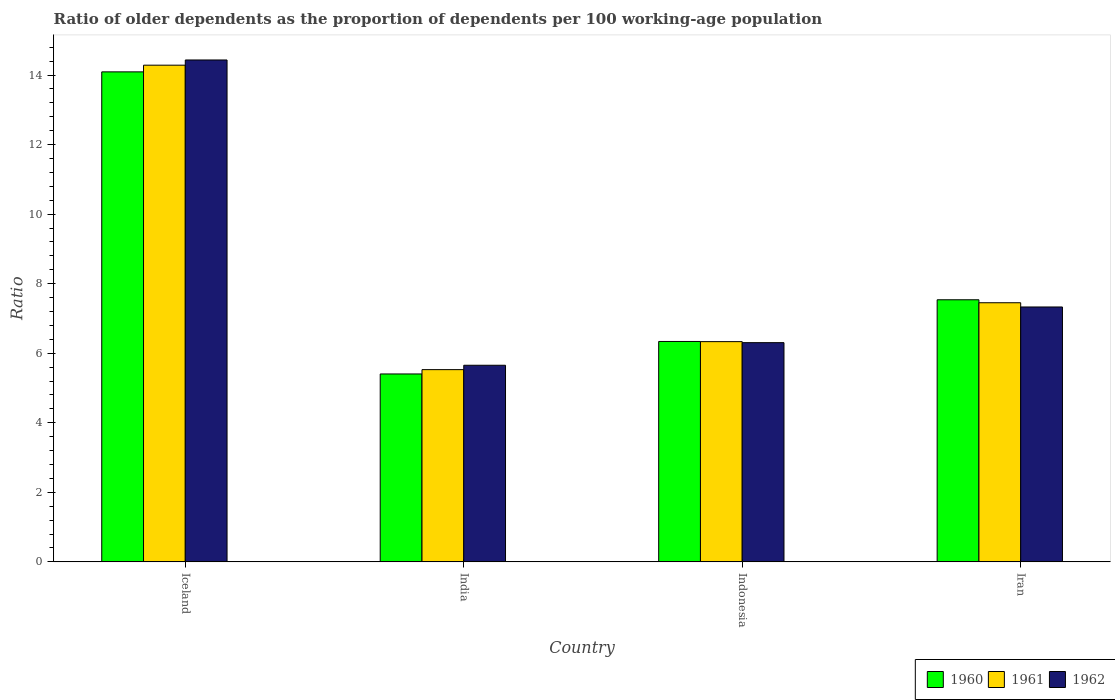How many groups of bars are there?
Your answer should be compact. 4. Are the number of bars per tick equal to the number of legend labels?
Offer a very short reply. Yes. What is the age dependency ratio(old) in 1960 in Iceland?
Your answer should be very brief. 14.09. Across all countries, what is the maximum age dependency ratio(old) in 1960?
Provide a short and direct response. 14.09. Across all countries, what is the minimum age dependency ratio(old) in 1962?
Offer a terse response. 5.65. In which country was the age dependency ratio(old) in 1962 maximum?
Offer a very short reply. Iceland. In which country was the age dependency ratio(old) in 1960 minimum?
Make the answer very short. India. What is the total age dependency ratio(old) in 1962 in the graph?
Keep it short and to the point. 33.72. What is the difference between the age dependency ratio(old) in 1962 in Iceland and that in Iran?
Give a very brief answer. 7.1. What is the difference between the age dependency ratio(old) in 1962 in Indonesia and the age dependency ratio(old) in 1961 in India?
Offer a terse response. 0.78. What is the average age dependency ratio(old) in 1961 per country?
Offer a terse response. 8.4. What is the difference between the age dependency ratio(old) of/in 1960 and age dependency ratio(old) of/in 1962 in Iceland?
Provide a succinct answer. -0.34. What is the ratio of the age dependency ratio(old) in 1961 in Iceland to that in India?
Give a very brief answer. 2.58. What is the difference between the highest and the second highest age dependency ratio(old) in 1960?
Your answer should be very brief. -7.75. What is the difference between the highest and the lowest age dependency ratio(old) in 1961?
Provide a succinct answer. 8.75. What does the 3rd bar from the left in Iran represents?
Give a very brief answer. 1962. What does the 2nd bar from the right in Indonesia represents?
Give a very brief answer. 1961. Is it the case that in every country, the sum of the age dependency ratio(old) in 1961 and age dependency ratio(old) in 1962 is greater than the age dependency ratio(old) in 1960?
Provide a short and direct response. Yes. What is the difference between two consecutive major ticks on the Y-axis?
Provide a short and direct response. 2. Does the graph contain any zero values?
Offer a terse response. No. Does the graph contain grids?
Offer a terse response. No. What is the title of the graph?
Provide a short and direct response. Ratio of older dependents as the proportion of dependents per 100 working-age population. Does "1994" appear as one of the legend labels in the graph?
Make the answer very short. No. What is the label or title of the X-axis?
Provide a short and direct response. Country. What is the label or title of the Y-axis?
Keep it short and to the point. Ratio. What is the Ratio in 1960 in Iceland?
Your answer should be compact. 14.09. What is the Ratio of 1961 in Iceland?
Your answer should be compact. 14.28. What is the Ratio of 1962 in Iceland?
Ensure brevity in your answer.  14.43. What is the Ratio in 1960 in India?
Your answer should be very brief. 5.4. What is the Ratio in 1961 in India?
Offer a very short reply. 5.53. What is the Ratio in 1962 in India?
Your response must be concise. 5.65. What is the Ratio in 1960 in Indonesia?
Offer a terse response. 6.34. What is the Ratio of 1961 in Indonesia?
Ensure brevity in your answer.  6.33. What is the Ratio of 1962 in Indonesia?
Make the answer very short. 6.3. What is the Ratio of 1960 in Iran?
Provide a short and direct response. 7.54. What is the Ratio of 1961 in Iran?
Your answer should be compact. 7.45. What is the Ratio in 1962 in Iran?
Provide a short and direct response. 7.33. Across all countries, what is the maximum Ratio of 1960?
Your answer should be very brief. 14.09. Across all countries, what is the maximum Ratio of 1961?
Keep it short and to the point. 14.28. Across all countries, what is the maximum Ratio in 1962?
Your answer should be very brief. 14.43. Across all countries, what is the minimum Ratio in 1960?
Provide a succinct answer. 5.4. Across all countries, what is the minimum Ratio of 1961?
Provide a succinct answer. 5.53. Across all countries, what is the minimum Ratio in 1962?
Make the answer very short. 5.65. What is the total Ratio in 1960 in the graph?
Keep it short and to the point. 33.37. What is the total Ratio of 1961 in the graph?
Ensure brevity in your answer.  33.6. What is the total Ratio in 1962 in the graph?
Ensure brevity in your answer.  33.72. What is the difference between the Ratio of 1960 in Iceland and that in India?
Provide a short and direct response. 8.69. What is the difference between the Ratio in 1961 in Iceland and that in India?
Your answer should be compact. 8.76. What is the difference between the Ratio of 1962 in Iceland and that in India?
Make the answer very short. 8.78. What is the difference between the Ratio of 1960 in Iceland and that in Indonesia?
Give a very brief answer. 7.75. What is the difference between the Ratio in 1961 in Iceland and that in Indonesia?
Provide a succinct answer. 7.95. What is the difference between the Ratio of 1962 in Iceland and that in Indonesia?
Offer a very short reply. 8.13. What is the difference between the Ratio in 1960 in Iceland and that in Iran?
Ensure brevity in your answer.  6.55. What is the difference between the Ratio of 1961 in Iceland and that in Iran?
Keep it short and to the point. 6.83. What is the difference between the Ratio of 1962 in Iceland and that in Iran?
Give a very brief answer. 7.1. What is the difference between the Ratio of 1960 in India and that in Indonesia?
Keep it short and to the point. -0.93. What is the difference between the Ratio of 1961 in India and that in Indonesia?
Keep it short and to the point. -0.81. What is the difference between the Ratio of 1962 in India and that in Indonesia?
Offer a very short reply. -0.65. What is the difference between the Ratio of 1960 in India and that in Iran?
Make the answer very short. -2.13. What is the difference between the Ratio of 1961 in India and that in Iran?
Keep it short and to the point. -1.92. What is the difference between the Ratio in 1962 in India and that in Iran?
Ensure brevity in your answer.  -1.68. What is the difference between the Ratio in 1960 in Indonesia and that in Iran?
Ensure brevity in your answer.  -1.2. What is the difference between the Ratio in 1961 in Indonesia and that in Iran?
Your answer should be very brief. -1.12. What is the difference between the Ratio of 1962 in Indonesia and that in Iran?
Your response must be concise. -1.03. What is the difference between the Ratio of 1960 in Iceland and the Ratio of 1961 in India?
Your answer should be very brief. 8.56. What is the difference between the Ratio of 1960 in Iceland and the Ratio of 1962 in India?
Offer a terse response. 8.44. What is the difference between the Ratio in 1961 in Iceland and the Ratio in 1962 in India?
Provide a succinct answer. 8.63. What is the difference between the Ratio of 1960 in Iceland and the Ratio of 1961 in Indonesia?
Your answer should be compact. 7.76. What is the difference between the Ratio in 1960 in Iceland and the Ratio in 1962 in Indonesia?
Give a very brief answer. 7.79. What is the difference between the Ratio of 1961 in Iceland and the Ratio of 1962 in Indonesia?
Give a very brief answer. 7.98. What is the difference between the Ratio of 1960 in Iceland and the Ratio of 1961 in Iran?
Your answer should be compact. 6.64. What is the difference between the Ratio of 1960 in Iceland and the Ratio of 1962 in Iran?
Your answer should be compact. 6.76. What is the difference between the Ratio of 1961 in Iceland and the Ratio of 1962 in Iran?
Ensure brevity in your answer.  6.95. What is the difference between the Ratio in 1960 in India and the Ratio in 1961 in Indonesia?
Provide a succinct answer. -0.93. What is the difference between the Ratio of 1960 in India and the Ratio of 1962 in Indonesia?
Offer a terse response. -0.9. What is the difference between the Ratio of 1961 in India and the Ratio of 1962 in Indonesia?
Your answer should be very brief. -0.78. What is the difference between the Ratio of 1960 in India and the Ratio of 1961 in Iran?
Your answer should be very brief. -2.05. What is the difference between the Ratio in 1960 in India and the Ratio in 1962 in Iran?
Ensure brevity in your answer.  -1.93. What is the difference between the Ratio of 1961 in India and the Ratio of 1962 in Iran?
Offer a terse response. -1.8. What is the difference between the Ratio of 1960 in Indonesia and the Ratio of 1961 in Iran?
Keep it short and to the point. -1.11. What is the difference between the Ratio in 1960 in Indonesia and the Ratio in 1962 in Iran?
Your answer should be compact. -0.99. What is the difference between the Ratio of 1961 in Indonesia and the Ratio of 1962 in Iran?
Keep it short and to the point. -1. What is the average Ratio in 1960 per country?
Make the answer very short. 8.34. What is the average Ratio in 1961 per country?
Your answer should be compact. 8.4. What is the average Ratio in 1962 per country?
Your answer should be compact. 8.43. What is the difference between the Ratio of 1960 and Ratio of 1961 in Iceland?
Your answer should be compact. -0.19. What is the difference between the Ratio of 1960 and Ratio of 1962 in Iceland?
Your response must be concise. -0.34. What is the difference between the Ratio of 1961 and Ratio of 1962 in Iceland?
Provide a short and direct response. -0.15. What is the difference between the Ratio of 1960 and Ratio of 1961 in India?
Your answer should be compact. -0.12. What is the difference between the Ratio in 1961 and Ratio in 1962 in India?
Offer a terse response. -0.13. What is the difference between the Ratio of 1960 and Ratio of 1961 in Indonesia?
Your answer should be very brief. 0.01. What is the difference between the Ratio of 1960 and Ratio of 1962 in Indonesia?
Make the answer very short. 0.03. What is the difference between the Ratio of 1961 and Ratio of 1962 in Indonesia?
Offer a very short reply. 0.03. What is the difference between the Ratio of 1960 and Ratio of 1961 in Iran?
Make the answer very short. 0.09. What is the difference between the Ratio in 1960 and Ratio in 1962 in Iran?
Your response must be concise. 0.21. What is the difference between the Ratio in 1961 and Ratio in 1962 in Iran?
Make the answer very short. 0.12. What is the ratio of the Ratio in 1960 in Iceland to that in India?
Your answer should be very brief. 2.61. What is the ratio of the Ratio of 1961 in Iceland to that in India?
Provide a succinct answer. 2.58. What is the ratio of the Ratio in 1962 in Iceland to that in India?
Offer a very short reply. 2.55. What is the ratio of the Ratio of 1960 in Iceland to that in Indonesia?
Offer a terse response. 2.22. What is the ratio of the Ratio of 1961 in Iceland to that in Indonesia?
Keep it short and to the point. 2.26. What is the ratio of the Ratio in 1962 in Iceland to that in Indonesia?
Keep it short and to the point. 2.29. What is the ratio of the Ratio in 1960 in Iceland to that in Iran?
Offer a very short reply. 1.87. What is the ratio of the Ratio of 1961 in Iceland to that in Iran?
Your response must be concise. 1.92. What is the ratio of the Ratio in 1962 in Iceland to that in Iran?
Provide a succinct answer. 1.97. What is the ratio of the Ratio of 1960 in India to that in Indonesia?
Provide a short and direct response. 0.85. What is the ratio of the Ratio of 1961 in India to that in Indonesia?
Offer a terse response. 0.87. What is the ratio of the Ratio in 1962 in India to that in Indonesia?
Ensure brevity in your answer.  0.9. What is the ratio of the Ratio in 1960 in India to that in Iran?
Make the answer very short. 0.72. What is the ratio of the Ratio in 1961 in India to that in Iran?
Offer a terse response. 0.74. What is the ratio of the Ratio of 1962 in India to that in Iran?
Provide a succinct answer. 0.77. What is the ratio of the Ratio of 1960 in Indonesia to that in Iran?
Offer a very short reply. 0.84. What is the ratio of the Ratio of 1961 in Indonesia to that in Iran?
Ensure brevity in your answer.  0.85. What is the ratio of the Ratio in 1962 in Indonesia to that in Iran?
Keep it short and to the point. 0.86. What is the difference between the highest and the second highest Ratio of 1960?
Offer a very short reply. 6.55. What is the difference between the highest and the second highest Ratio in 1961?
Your answer should be compact. 6.83. What is the difference between the highest and the second highest Ratio in 1962?
Keep it short and to the point. 7.1. What is the difference between the highest and the lowest Ratio in 1960?
Give a very brief answer. 8.69. What is the difference between the highest and the lowest Ratio in 1961?
Your response must be concise. 8.76. What is the difference between the highest and the lowest Ratio of 1962?
Make the answer very short. 8.78. 